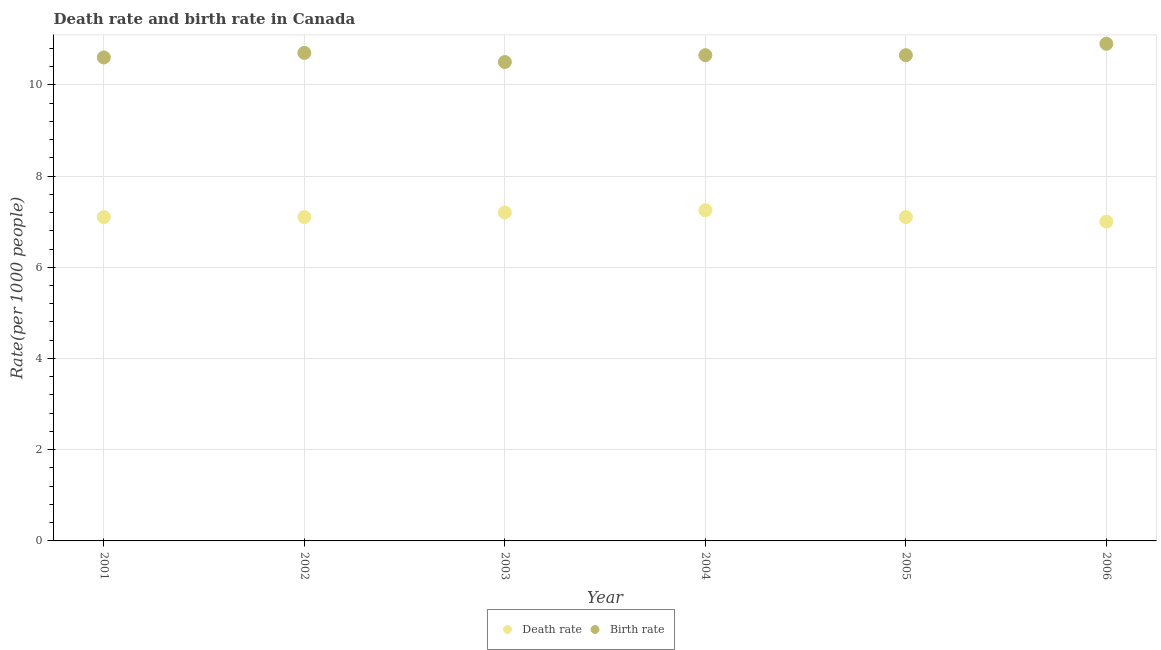What is the birth rate in 2001?
Ensure brevity in your answer.  10.6. Across all years, what is the minimum death rate?
Provide a succinct answer. 7. In which year was the death rate maximum?
Give a very brief answer. 2004. What is the total birth rate in the graph?
Provide a short and direct response. 64. What is the difference between the birth rate in 2002 and that in 2005?
Give a very brief answer. 0.05. What is the difference between the birth rate in 2006 and the death rate in 2004?
Your answer should be very brief. 3.65. What is the average birth rate per year?
Make the answer very short. 10.67. In the year 2001, what is the difference between the birth rate and death rate?
Your answer should be very brief. 3.5. In how many years, is the death rate greater than 4.8?
Give a very brief answer. 6. What is the ratio of the birth rate in 2003 to that in 2005?
Provide a succinct answer. 0.99. Is the birth rate in 2003 less than that in 2005?
Offer a terse response. Yes. Is the difference between the death rate in 2002 and 2005 greater than the difference between the birth rate in 2002 and 2005?
Ensure brevity in your answer.  No. What is the difference between the highest and the second highest birth rate?
Your response must be concise. 0.2. In how many years, is the birth rate greater than the average birth rate taken over all years?
Offer a terse response. 2. Is the sum of the birth rate in 2002 and 2003 greater than the maximum death rate across all years?
Offer a very short reply. Yes. Is the birth rate strictly less than the death rate over the years?
Keep it short and to the point. No. How many dotlines are there?
Provide a succinct answer. 2. How many years are there in the graph?
Keep it short and to the point. 6. Are the values on the major ticks of Y-axis written in scientific E-notation?
Offer a terse response. No. How many legend labels are there?
Offer a terse response. 2. How are the legend labels stacked?
Give a very brief answer. Horizontal. What is the title of the graph?
Offer a terse response. Death rate and birth rate in Canada. Does "Commercial service imports" appear as one of the legend labels in the graph?
Offer a very short reply. No. What is the label or title of the X-axis?
Ensure brevity in your answer.  Year. What is the label or title of the Y-axis?
Offer a terse response. Rate(per 1000 people). What is the Rate(per 1000 people) of Birth rate in 2001?
Make the answer very short. 10.6. What is the Rate(per 1000 people) in Death rate in 2003?
Offer a very short reply. 7.2. What is the Rate(per 1000 people) of Birth rate in 2003?
Ensure brevity in your answer.  10.5. What is the Rate(per 1000 people) of Death rate in 2004?
Offer a terse response. 7.25. What is the Rate(per 1000 people) in Birth rate in 2004?
Make the answer very short. 10.65. What is the Rate(per 1000 people) of Birth rate in 2005?
Provide a short and direct response. 10.65. Across all years, what is the maximum Rate(per 1000 people) in Death rate?
Offer a terse response. 7.25. Across all years, what is the maximum Rate(per 1000 people) of Birth rate?
Provide a short and direct response. 10.9. What is the total Rate(per 1000 people) of Death rate in the graph?
Give a very brief answer. 42.75. What is the difference between the Rate(per 1000 people) in Death rate in 2001 and that in 2002?
Offer a very short reply. 0. What is the difference between the Rate(per 1000 people) in Birth rate in 2001 and that in 2002?
Make the answer very short. -0.1. What is the difference between the Rate(per 1000 people) in Death rate in 2001 and that in 2003?
Your response must be concise. -0.1. What is the difference between the Rate(per 1000 people) in Birth rate in 2001 and that in 2003?
Make the answer very short. 0.1. What is the difference between the Rate(per 1000 people) of Death rate in 2001 and that in 2005?
Make the answer very short. 0. What is the difference between the Rate(per 1000 people) in Birth rate in 2001 and that in 2005?
Provide a short and direct response. -0.05. What is the difference between the Rate(per 1000 people) in Death rate in 2002 and that in 2003?
Keep it short and to the point. -0.1. What is the difference between the Rate(per 1000 people) in Death rate in 2002 and that in 2004?
Your response must be concise. -0.15. What is the difference between the Rate(per 1000 people) in Birth rate in 2003 and that in 2004?
Keep it short and to the point. -0.15. What is the difference between the Rate(per 1000 people) in Birth rate in 2003 and that in 2005?
Your answer should be very brief. -0.15. What is the difference between the Rate(per 1000 people) in Death rate in 2003 and that in 2006?
Offer a terse response. 0.2. What is the difference between the Rate(per 1000 people) in Death rate in 2004 and that in 2005?
Your answer should be very brief. 0.15. What is the difference between the Rate(per 1000 people) in Birth rate in 2004 and that in 2005?
Your answer should be compact. 0. What is the difference between the Rate(per 1000 people) of Birth rate in 2004 and that in 2006?
Ensure brevity in your answer.  -0.25. What is the difference between the Rate(per 1000 people) of Death rate in 2005 and that in 2006?
Give a very brief answer. 0.1. What is the difference between the Rate(per 1000 people) in Death rate in 2001 and the Rate(per 1000 people) in Birth rate in 2003?
Offer a terse response. -3.4. What is the difference between the Rate(per 1000 people) of Death rate in 2001 and the Rate(per 1000 people) of Birth rate in 2004?
Make the answer very short. -3.55. What is the difference between the Rate(per 1000 people) of Death rate in 2001 and the Rate(per 1000 people) of Birth rate in 2005?
Your answer should be very brief. -3.55. What is the difference between the Rate(per 1000 people) in Death rate in 2002 and the Rate(per 1000 people) in Birth rate in 2004?
Offer a terse response. -3.55. What is the difference between the Rate(per 1000 people) of Death rate in 2002 and the Rate(per 1000 people) of Birth rate in 2005?
Give a very brief answer. -3.55. What is the difference between the Rate(per 1000 people) of Death rate in 2002 and the Rate(per 1000 people) of Birth rate in 2006?
Give a very brief answer. -3.8. What is the difference between the Rate(per 1000 people) of Death rate in 2003 and the Rate(per 1000 people) of Birth rate in 2004?
Keep it short and to the point. -3.45. What is the difference between the Rate(per 1000 people) in Death rate in 2003 and the Rate(per 1000 people) in Birth rate in 2005?
Give a very brief answer. -3.45. What is the difference between the Rate(per 1000 people) in Death rate in 2003 and the Rate(per 1000 people) in Birth rate in 2006?
Offer a terse response. -3.7. What is the difference between the Rate(per 1000 people) of Death rate in 2004 and the Rate(per 1000 people) of Birth rate in 2005?
Your response must be concise. -3.4. What is the difference between the Rate(per 1000 people) of Death rate in 2004 and the Rate(per 1000 people) of Birth rate in 2006?
Your answer should be very brief. -3.65. What is the average Rate(per 1000 people) of Death rate per year?
Give a very brief answer. 7.12. What is the average Rate(per 1000 people) in Birth rate per year?
Your response must be concise. 10.67. In the year 2001, what is the difference between the Rate(per 1000 people) of Death rate and Rate(per 1000 people) of Birth rate?
Keep it short and to the point. -3.5. In the year 2002, what is the difference between the Rate(per 1000 people) of Death rate and Rate(per 1000 people) of Birth rate?
Your response must be concise. -3.6. In the year 2003, what is the difference between the Rate(per 1000 people) in Death rate and Rate(per 1000 people) in Birth rate?
Give a very brief answer. -3.3. In the year 2005, what is the difference between the Rate(per 1000 people) of Death rate and Rate(per 1000 people) of Birth rate?
Your response must be concise. -3.55. In the year 2006, what is the difference between the Rate(per 1000 people) of Death rate and Rate(per 1000 people) of Birth rate?
Make the answer very short. -3.9. What is the ratio of the Rate(per 1000 people) in Death rate in 2001 to that in 2002?
Provide a succinct answer. 1. What is the ratio of the Rate(per 1000 people) in Death rate in 2001 to that in 2003?
Offer a terse response. 0.99. What is the ratio of the Rate(per 1000 people) in Birth rate in 2001 to that in 2003?
Give a very brief answer. 1.01. What is the ratio of the Rate(per 1000 people) of Death rate in 2001 to that in 2004?
Provide a succinct answer. 0.98. What is the ratio of the Rate(per 1000 people) in Birth rate in 2001 to that in 2004?
Keep it short and to the point. 1. What is the ratio of the Rate(per 1000 people) in Birth rate in 2001 to that in 2005?
Your answer should be very brief. 1. What is the ratio of the Rate(per 1000 people) of Death rate in 2001 to that in 2006?
Provide a short and direct response. 1.01. What is the ratio of the Rate(per 1000 people) of Birth rate in 2001 to that in 2006?
Provide a short and direct response. 0.97. What is the ratio of the Rate(per 1000 people) in Death rate in 2002 to that in 2003?
Provide a short and direct response. 0.99. What is the ratio of the Rate(per 1000 people) of Death rate in 2002 to that in 2004?
Provide a succinct answer. 0.98. What is the ratio of the Rate(per 1000 people) in Birth rate in 2002 to that in 2004?
Provide a succinct answer. 1. What is the ratio of the Rate(per 1000 people) of Birth rate in 2002 to that in 2005?
Make the answer very short. 1. What is the ratio of the Rate(per 1000 people) of Death rate in 2002 to that in 2006?
Keep it short and to the point. 1.01. What is the ratio of the Rate(per 1000 people) in Birth rate in 2002 to that in 2006?
Keep it short and to the point. 0.98. What is the ratio of the Rate(per 1000 people) in Birth rate in 2003 to that in 2004?
Provide a succinct answer. 0.99. What is the ratio of the Rate(per 1000 people) of Death rate in 2003 to that in 2005?
Give a very brief answer. 1.01. What is the ratio of the Rate(per 1000 people) in Birth rate in 2003 to that in 2005?
Your response must be concise. 0.99. What is the ratio of the Rate(per 1000 people) in Death rate in 2003 to that in 2006?
Keep it short and to the point. 1.03. What is the ratio of the Rate(per 1000 people) in Birth rate in 2003 to that in 2006?
Your answer should be compact. 0.96. What is the ratio of the Rate(per 1000 people) in Death rate in 2004 to that in 2005?
Ensure brevity in your answer.  1.02. What is the ratio of the Rate(per 1000 people) of Birth rate in 2004 to that in 2005?
Provide a succinct answer. 1. What is the ratio of the Rate(per 1000 people) of Death rate in 2004 to that in 2006?
Your response must be concise. 1.04. What is the ratio of the Rate(per 1000 people) in Birth rate in 2004 to that in 2006?
Keep it short and to the point. 0.98. What is the ratio of the Rate(per 1000 people) in Death rate in 2005 to that in 2006?
Offer a terse response. 1.01. What is the ratio of the Rate(per 1000 people) of Birth rate in 2005 to that in 2006?
Your answer should be very brief. 0.98. What is the difference between the highest and the lowest Rate(per 1000 people) of Death rate?
Provide a succinct answer. 0.25. What is the difference between the highest and the lowest Rate(per 1000 people) of Birth rate?
Give a very brief answer. 0.4. 